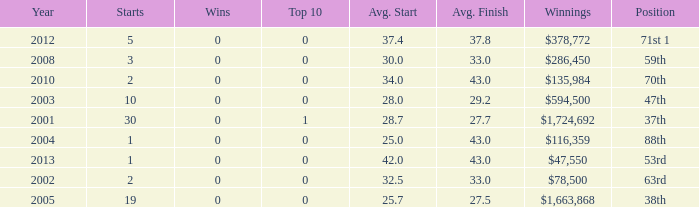How many wins for average start less than 25? 0.0. 